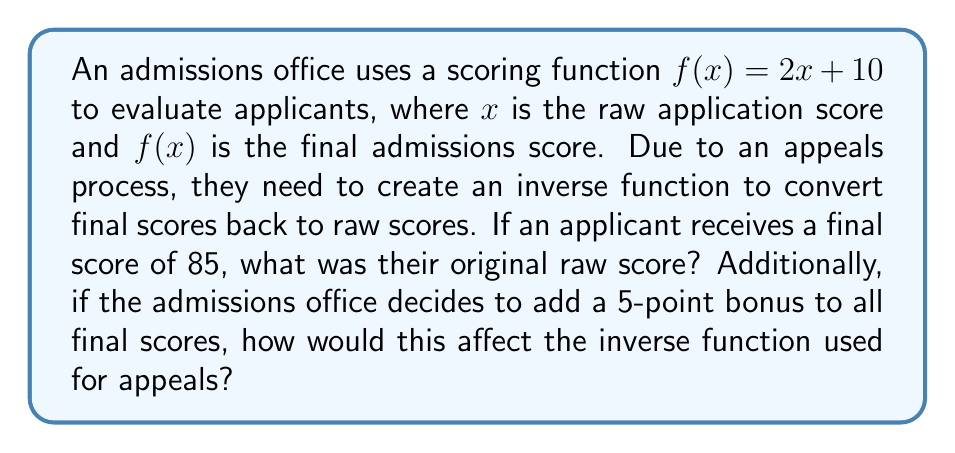Can you solve this math problem? To solve this problem, we need to follow these steps:

1. Find the inverse function of $f(x) = 2x + 10$:
   Let $y = f(x) = 2x + 10$
   Swap $x$ and $y$: $x = 2y + 10$
   Solve for $y$: 
   $x - 10 = 2y$
   $\frac{x - 10}{2} = y$
   Therefore, $f^{-1}(x) = \frac{x - 10}{2}$

2. Use the inverse function to find the original raw score for a final score of 85:
   $f^{-1}(85) = \frac{85 - 10}{2} = \frac{75}{2} = 37.5$

3. For the 5-point bonus, we need to transform the original function:
   New function: $g(x) = f(x) + 5 = (2x + 10) + 5 = 2x + 15$

4. Find the inverse of the new function $g(x)$:
   Let $y = g(x) = 2x + 15$
   Swap $x$ and $y$: $x = 2y + 15$
   Solve for $y$:
   $x - 15 = 2y$
   $\frac{x - 15}{2} = y$
   Therefore, $g^{-1}(x) = \frac{x - 15}{2}$

This new inverse function would be used for appeals after the 5-point bonus is applied.
Answer: The original raw score for a final score of 85 is 37.5. After adding a 5-point bonus to all final scores, the new inverse function for appeals would be $g^{-1}(x) = \frac{x - 15}{2}$. 